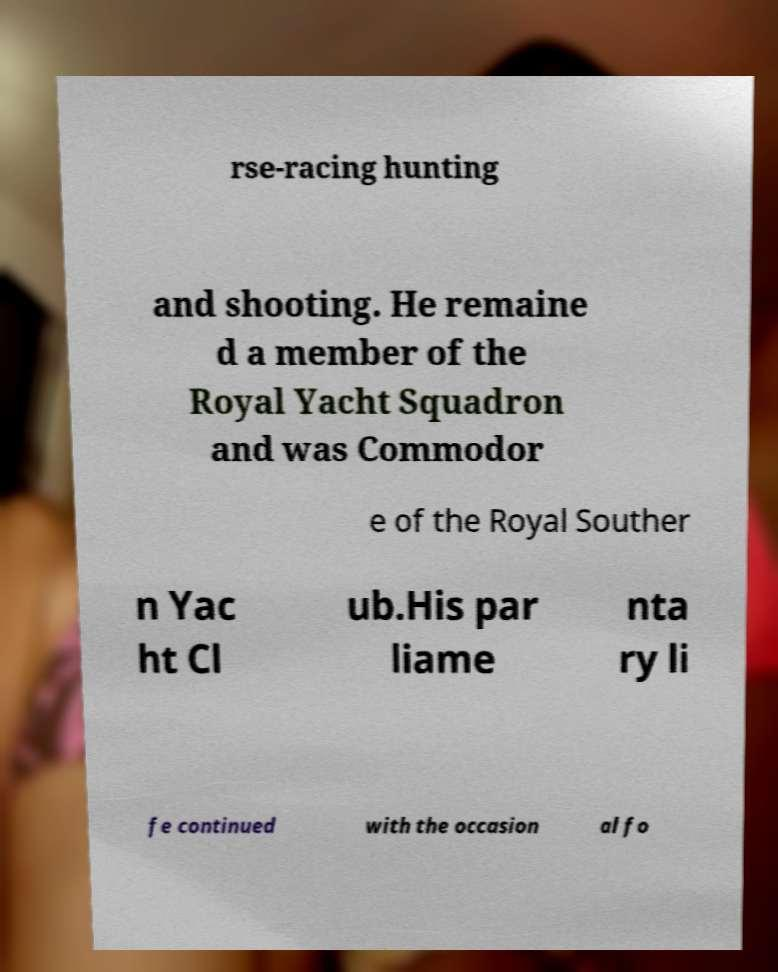Can you accurately transcribe the text from the provided image for me? rse-racing hunting and shooting. He remaine d a member of the Royal Yacht Squadron and was Commodor e of the Royal Souther n Yac ht Cl ub.His par liame nta ry li fe continued with the occasion al fo 